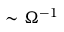Convert formula to latex. <formula><loc_0><loc_0><loc_500><loc_500>\sim \Omega ^ { - 1 }</formula> 